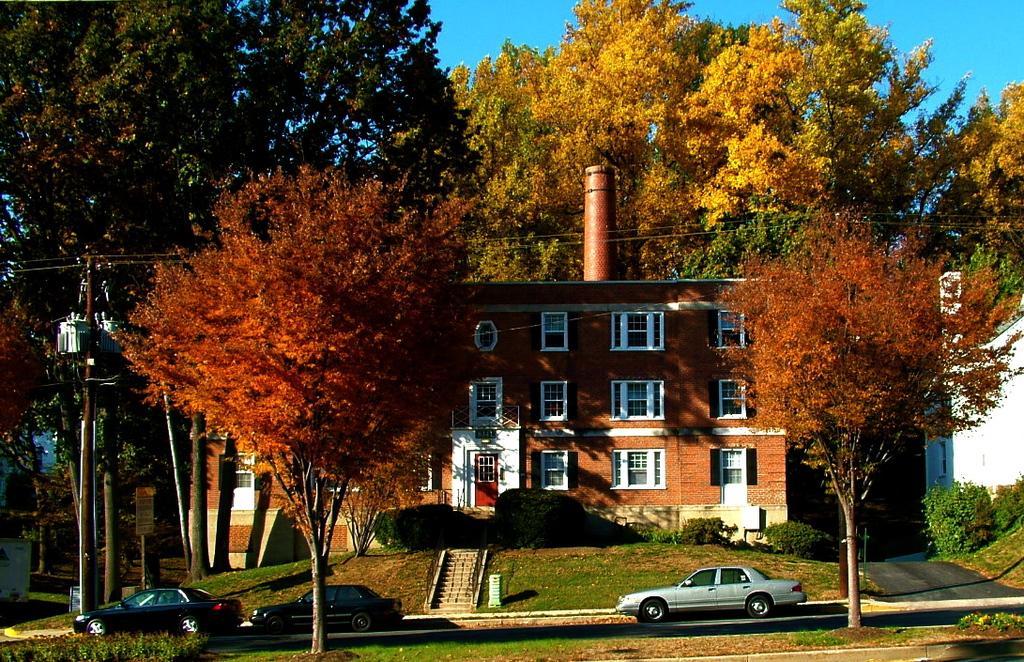Can you describe this image briefly? In the foreground of this image, there are trees and few vehicles moving on the road. We can also see few buildings, cables, poles and the sky. 